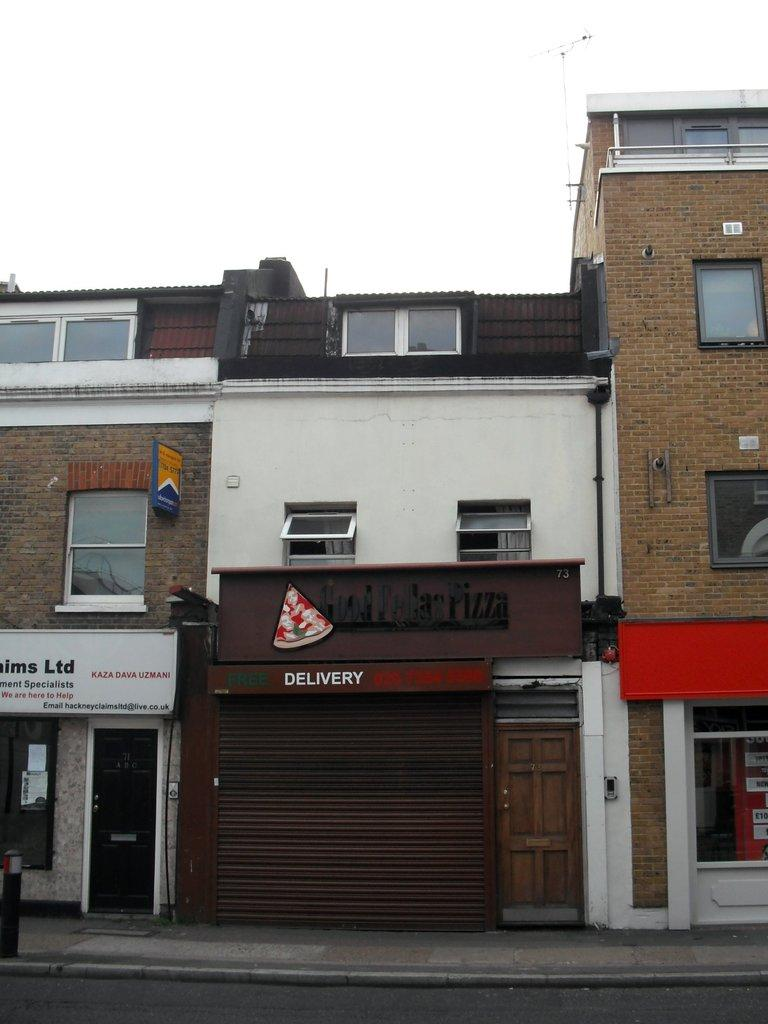What type of structures can be seen in the image? There are buildings in the image. What feature is present on the buildings? There are glass windows and doors on the buildings. What type of advertisements or signs are visible on the buildings? There are hoardings on the buildings. How many caps can be seen on the roof of the buildings in the image? There are no caps visible on the roof of the buildings in the image. What type of pizzas are being served in the image? There are no pizzas present in the image. 